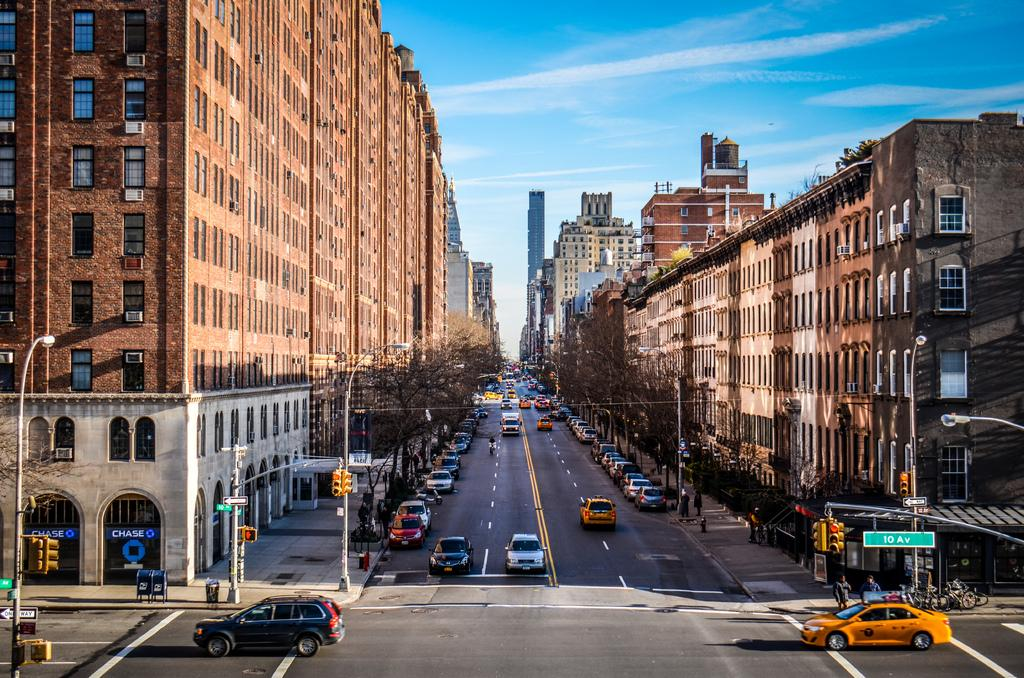<image>
Present a compact description of the photo's key features. The bank to the left of the street is a chase bank 